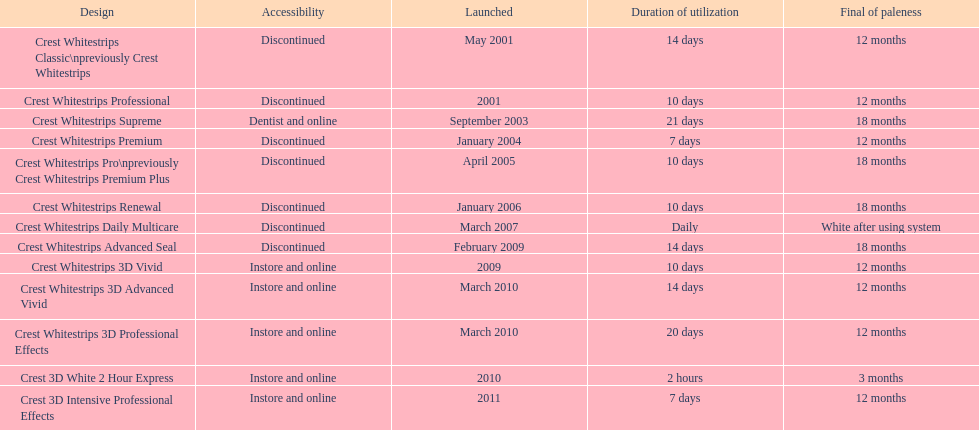Which model has the highest 'length of use' to 'last of whiteness' ratio? Crest Whitestrips Supreme. 